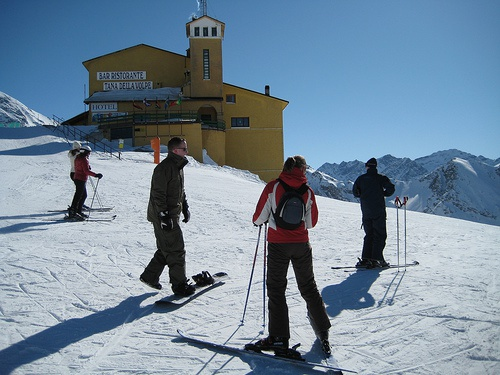Describe the objects in this image and their specific colors. I can see people in darkblue, black, maroon, gray, and darkgray tones, people in darkblue, black, lightgray, gray, and darkgray tones, people in darkblue, black, gray, navy, and lightgray tones, skis in darkblue, black, navy, blue, and lightgray tones, and backpack in darkblue, black, gray, and maroon tones in this image. 